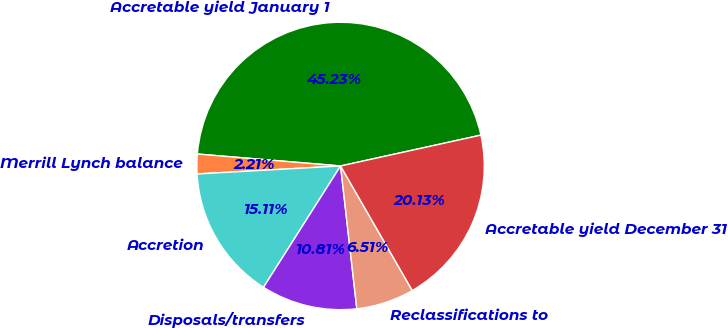<chart> <loc_0><loc_0><loc_500><loc_500><pie_chart><fcel>Accretable yield January 1<fcel>Merrill Lynch balance<fcel>Accretion<fcel>Disposals/transfers<fcel>Reclassifications to<fcel>Accretable yield December 31<nl><fcel>45.23%<fcel>2.21%<fcel>15.11%<fcel>10.81%<fcel>6.51%<fcel>20.13%<nl></chart> 